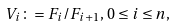Convert formula to latex. <formula><loc_0><loc_0><loc_500><loc_500>V _ { i } \colon = F _ { i } / F _ { i + 1 } , \, 0 \leq i \leq n ,</formula> 